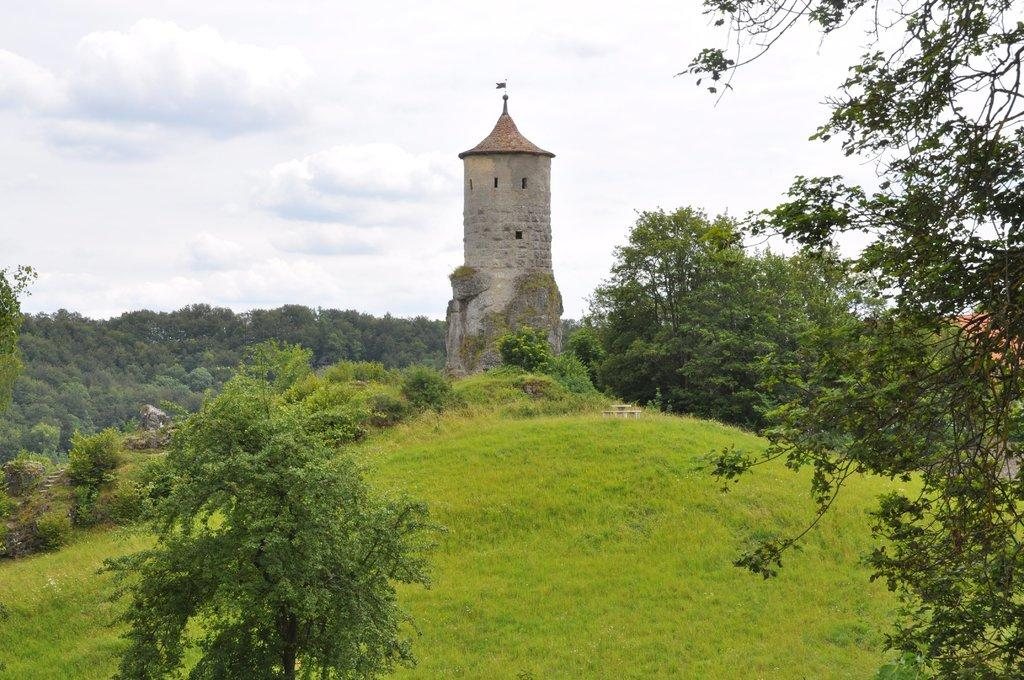What type of vegetation is present in the image? There are plants and trees in the image. What color are the plants and trees? The plants and trees are green. What structure can be seen in the background of the image? There is a lighthouse in the background of the image. What is the color of the sky in the image? The sky is white in color. Can you see a girl with a baseball in the image? There is no girl or baseball present in the image. 